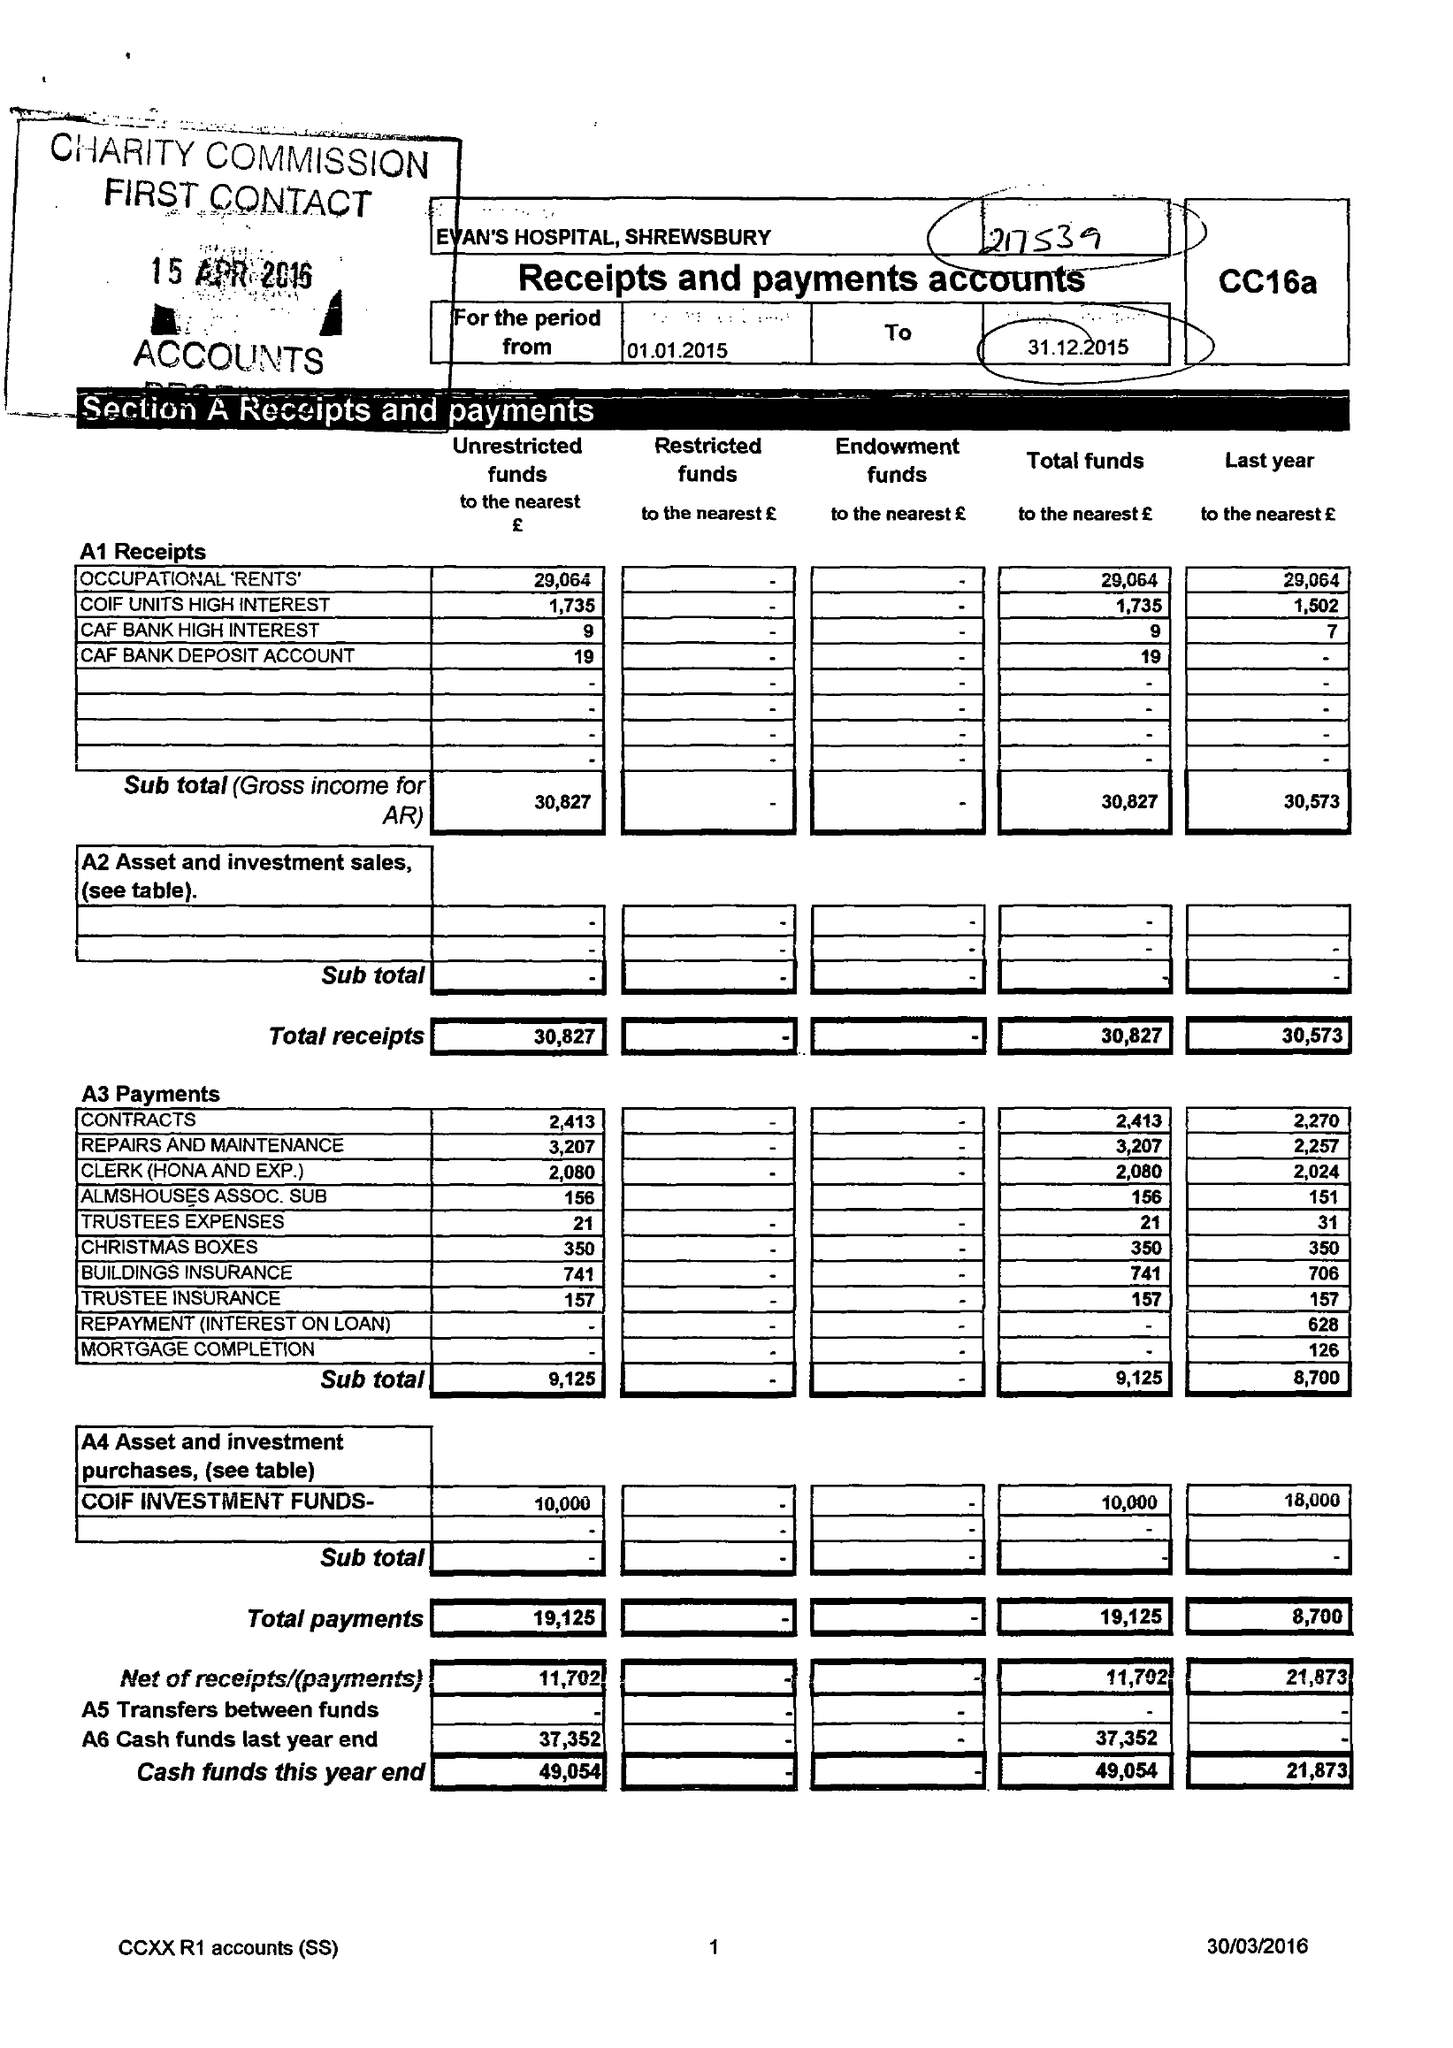What is the value for the charity_name?
Answer the question using a single word or phrase. Evans's Hospital 